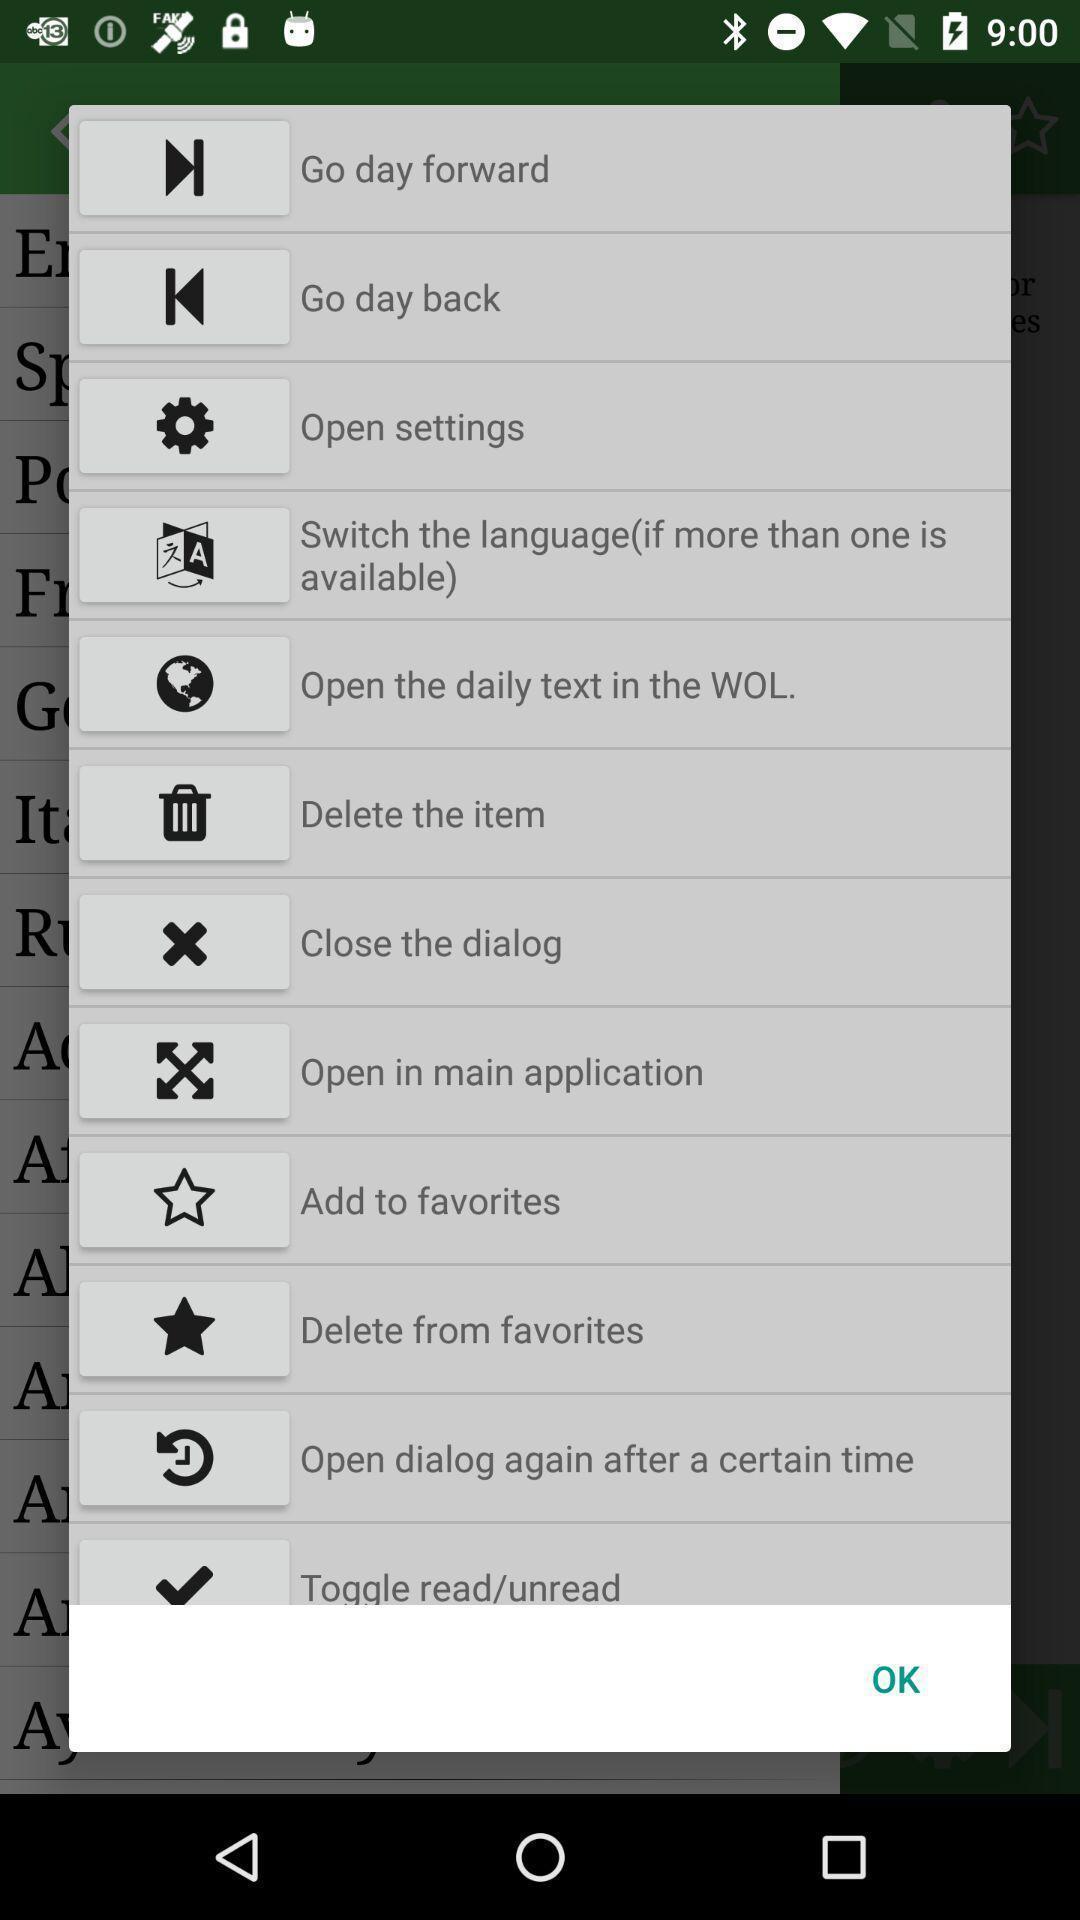Tell me what you see in this picture. Popup of different options in the language learning app. 